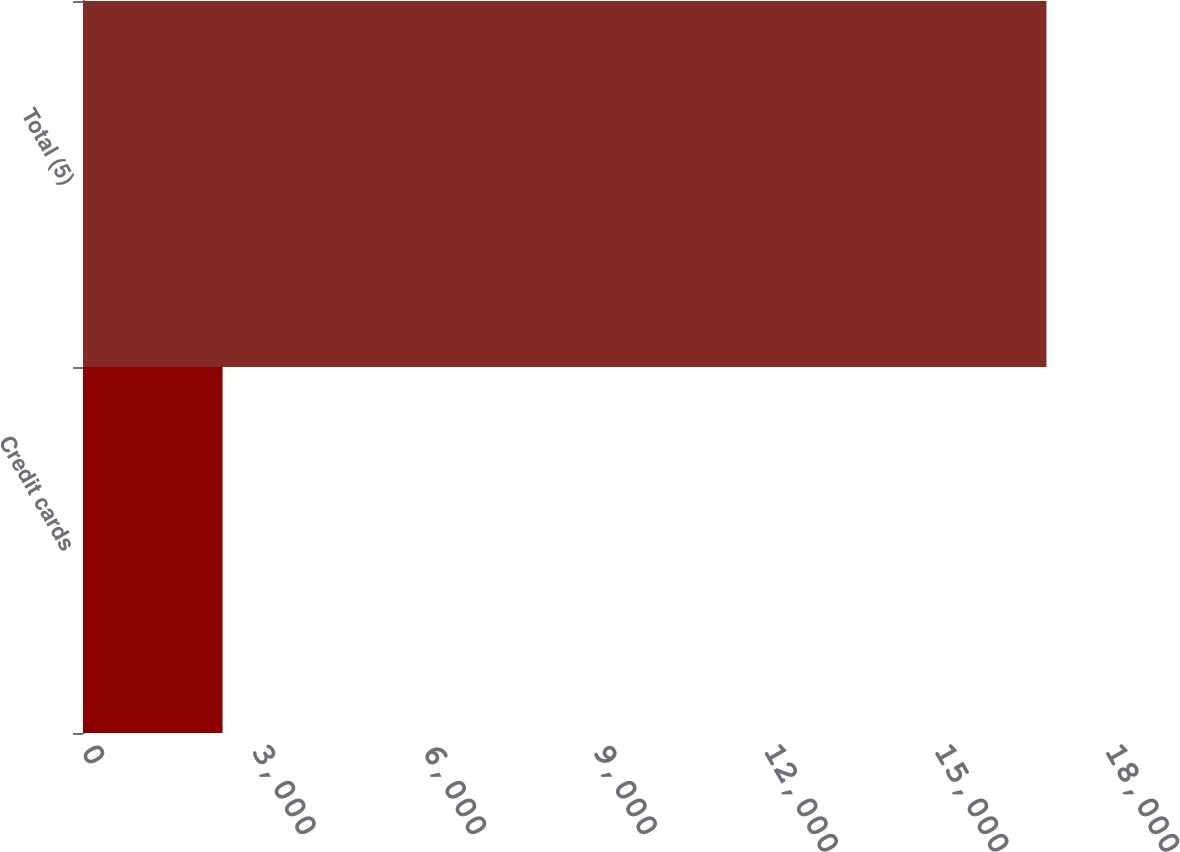<chart> <loc_0><loc_0><loc_500><loc_500><bar_chart><fcel>Credit cards<fcel>Total (5)<nl><fcel>2453<fcel>16935<nl></chart> 